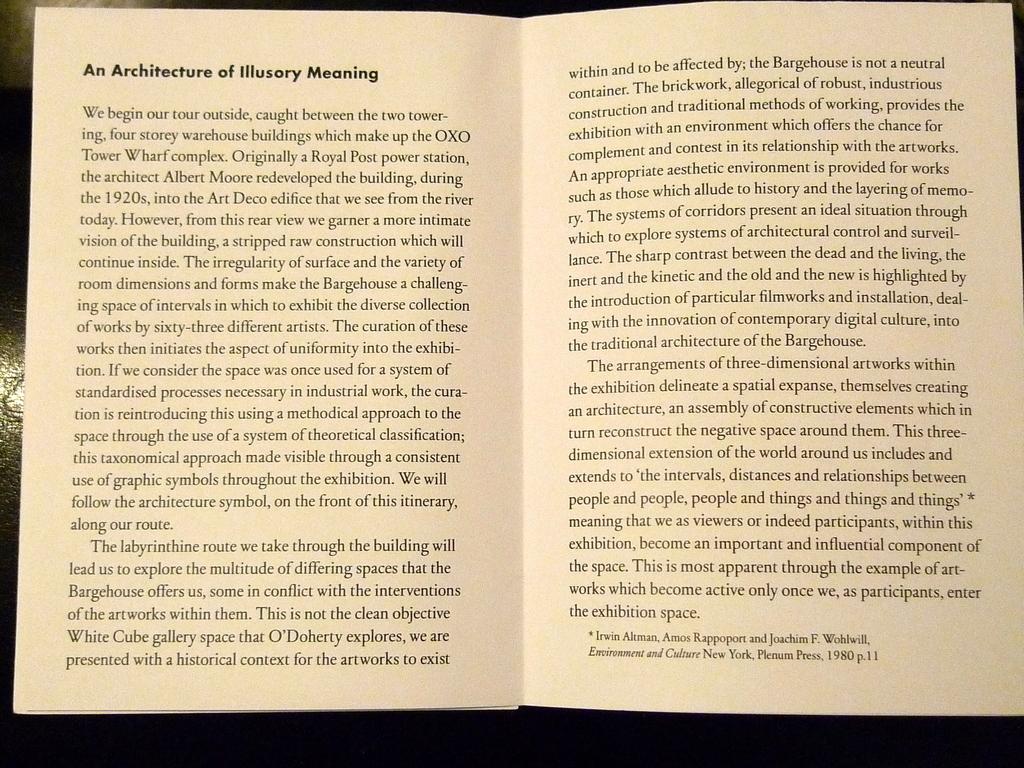What is the first word on the left hand page?
Provide a short and direct response. An. 